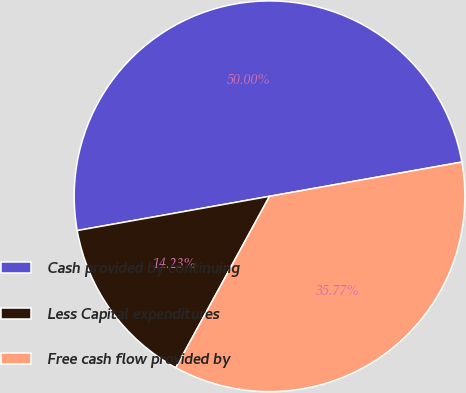Convert chart. <chart><loc_0><loc_0><loc_500><loc_500><pie_chart><fcel>Cash provided by continuing<fcel>Less Capital expenditures<fcel>Free cash flow provided by<nl><fcel>50.0%<fcel>14.23%<fcel>35.77%<nl></chart> 